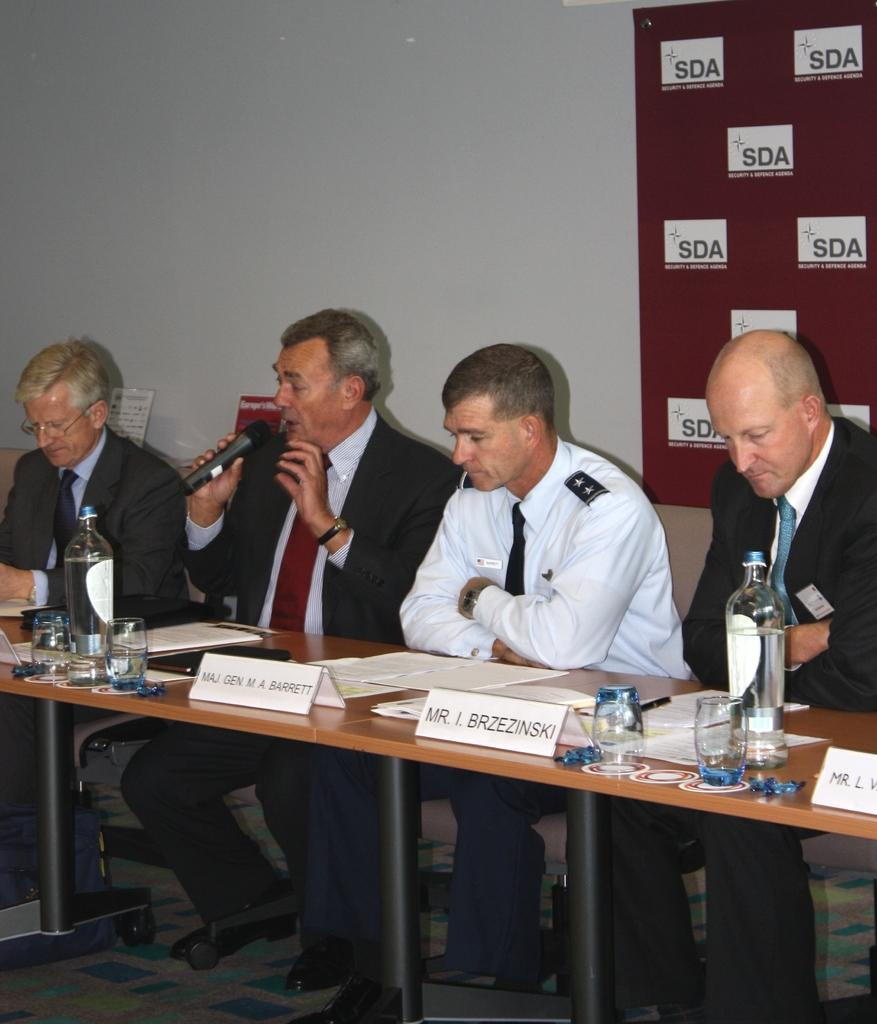How many people are in the image? There is a group of persons in the image. What are the persons doing in the image? The persons are sitting on chairs. What objects are on the table in the image? There are bottles and glasses on the table. Can you see any kittens playing on the grass in the image? There is no grass or kittens present in the image. 